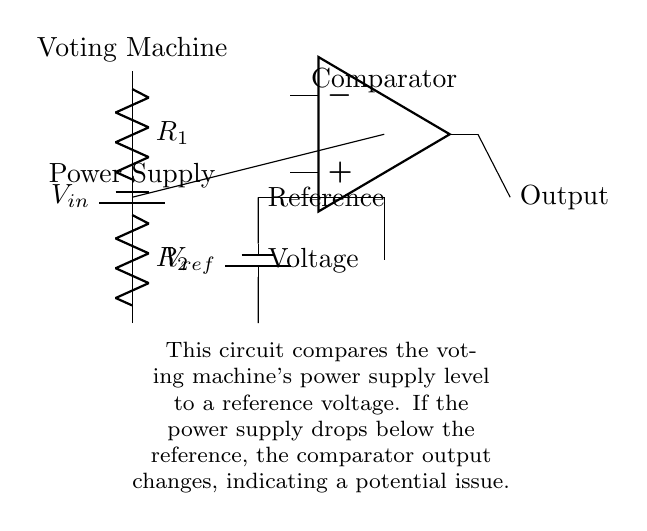What are the components used in the circuit? The circuit includes a battery for the input voltage, two resistors forming a voltage divider, a reference voltage source, and an operational amplifier functioning as a comparator.
Answer: battery, resistors, operational amplifier What is the role of the resistors in this circuit? The resistors R1 and R2 create a voltage divider that produces a variable voltage level from the input voltage, which is then compared to the reference voltage by the comparator.
Answer: voltage divider What does the comparator's output indicate? The output of the comparator changes state whenever the power supply level falls below the reference voltage, thereby signaling a potential issue in the voting machine's power supply.
Answer: indicates a potential issue What is the value of the reference voltage represented by the source? The reference voltage is indicated as being represented by a reference battery in the diagram, but the actual voltage value is not specified within the circuit; it would need to be defined based on system requirements.
Answer: not specified What happens to the comparator's output if the power supply drops below reference? If the power supply drops below the reference level, the comparator will change its output state to indicate an issue, typically resulting in a low or high signal depending on the specific comparator configuration.
Answer: changes state What does the label 'Voting Machine' represent in the context of the circuit? The label 'Voting Machine' identifies the source of the input voltage (V_in) that powers the circuit and suggests that the system is designed for monitoring the operational status of voting machines.
Answer: input voltage source What is the sequential order of voltage detection in this circuit? The sequence starts from the voting machine providing the input voltage, which is then divided by the resistors R1 and R2 to create a comparison voltage, and finally, this is compared to the reference voltage at the input of the comparator.
Answer: voting machine to resistors to comparator 